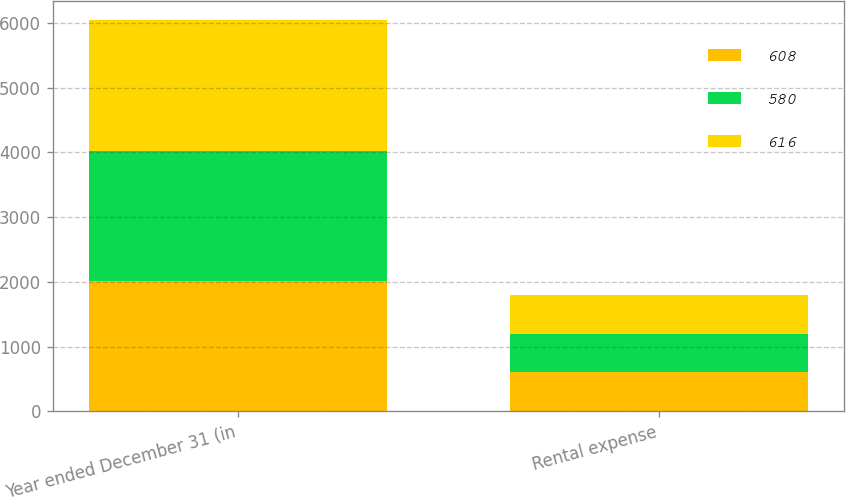Convert chart. <chart><loc_0><loc_0><loc_500><loc_500><stacked_bar_chart><ecel><fcel>Year ended December 31 (in<fcel>Rental expense<nl><fcel>608<fcel>2015<fcel>608<nl><fcel>580<fcel>2014<fcel>580<nl><fcel>616<fcel>2013<fcel>616<nl></chart> 